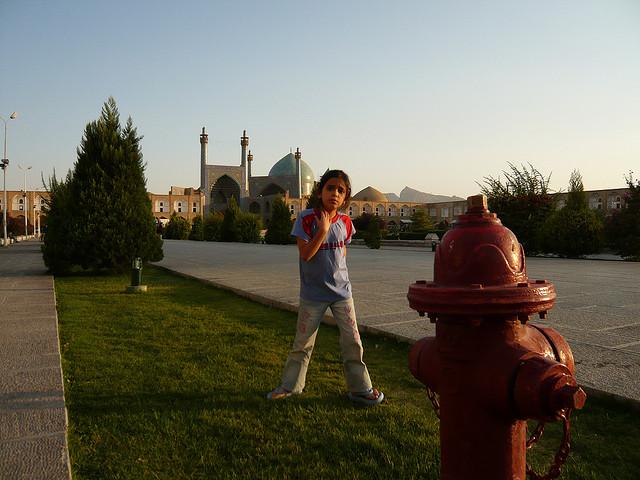Where is the girl's left arm?
Be succinct. Behind her back. What color is the fire hydrant?
Keep it brief. Red. How many children are here?
Give a very brief answer. 1. 